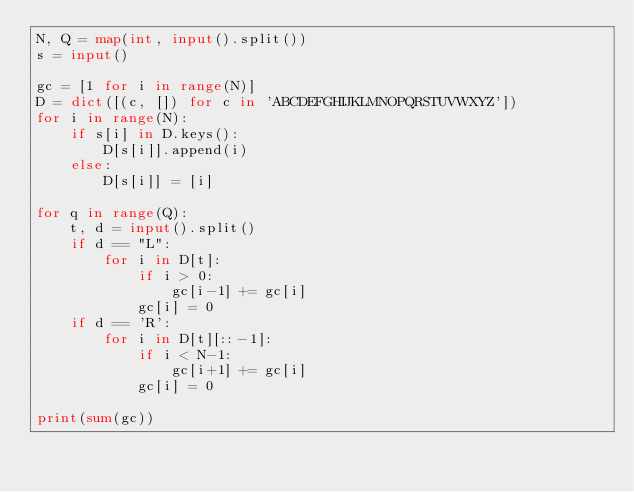Convert code to text. <code><loc_0><loc_0><loc_500><loc_500><_Python_>N, Q = map(int, input().split())
s = input()

gc = [1 for i in range(N)]
D = dict([(c, []) for c in 'ABCDEFGHIJKLMNOPQRSTUVWXYZ'])
for i in range(N):
    if s[i] in D.keys():
        D[s[i]].append(i)
    else:
        D[s[i]] = [i]

for q in range(Q):
    t, d = input().split()
    if d == "L":
        for i in D[t]:
            if i > 0:
                gc[i-1] += gc[i]
            gc[i] = 0
    if d == 'R':
        for i in D[t][::-1]:
            if i < N-1:
                gc[i+1] += gc[i]
            gc[i] = 0

print(sum(gc))
</code> 